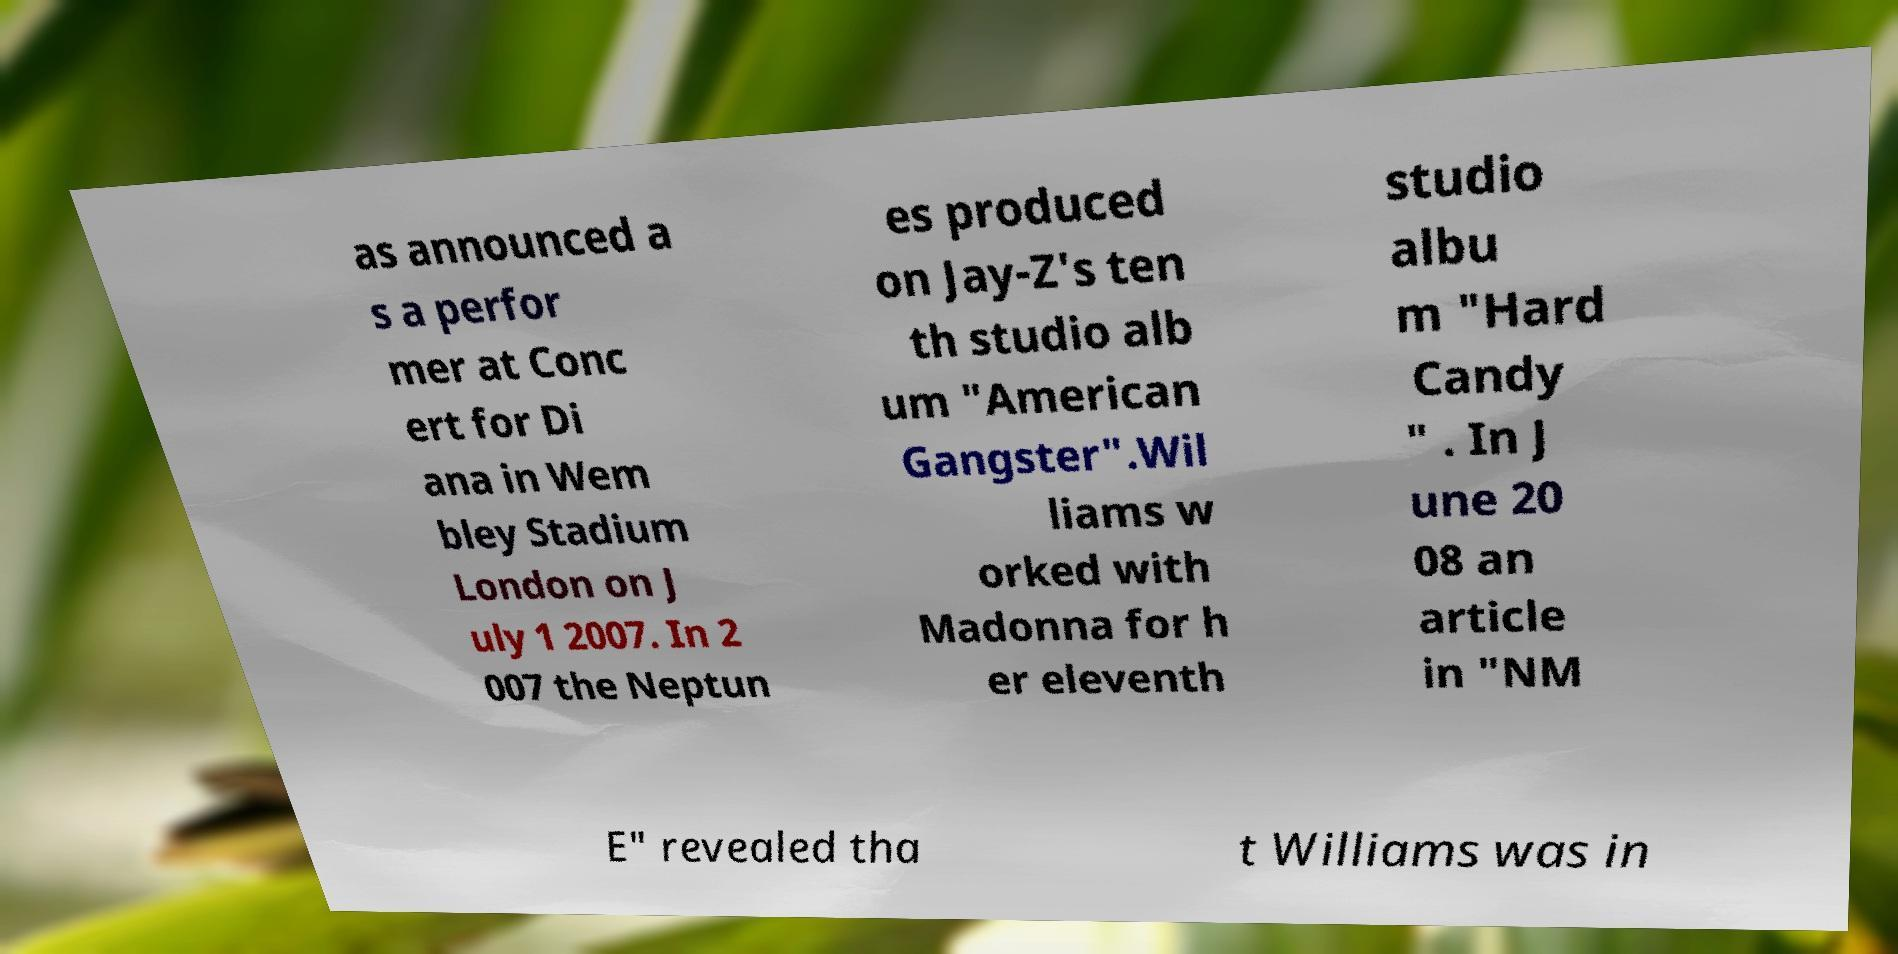For documentation purposes, I need the text within this image transcribed. Could you provide that? as announced a s a perfor mer at Conc ert for Di ana in Wem bley Stadium London on J uly 1 2007. In 2 007 the Neptun es produced on Jay-Z's ten th studio alb um "American Gangster".Wil liams w orked with Madonna for h er eleventh studio albu m "Hard Candy " . In J une 20 08 an article in "NM E" revealed tha t Williams was in 